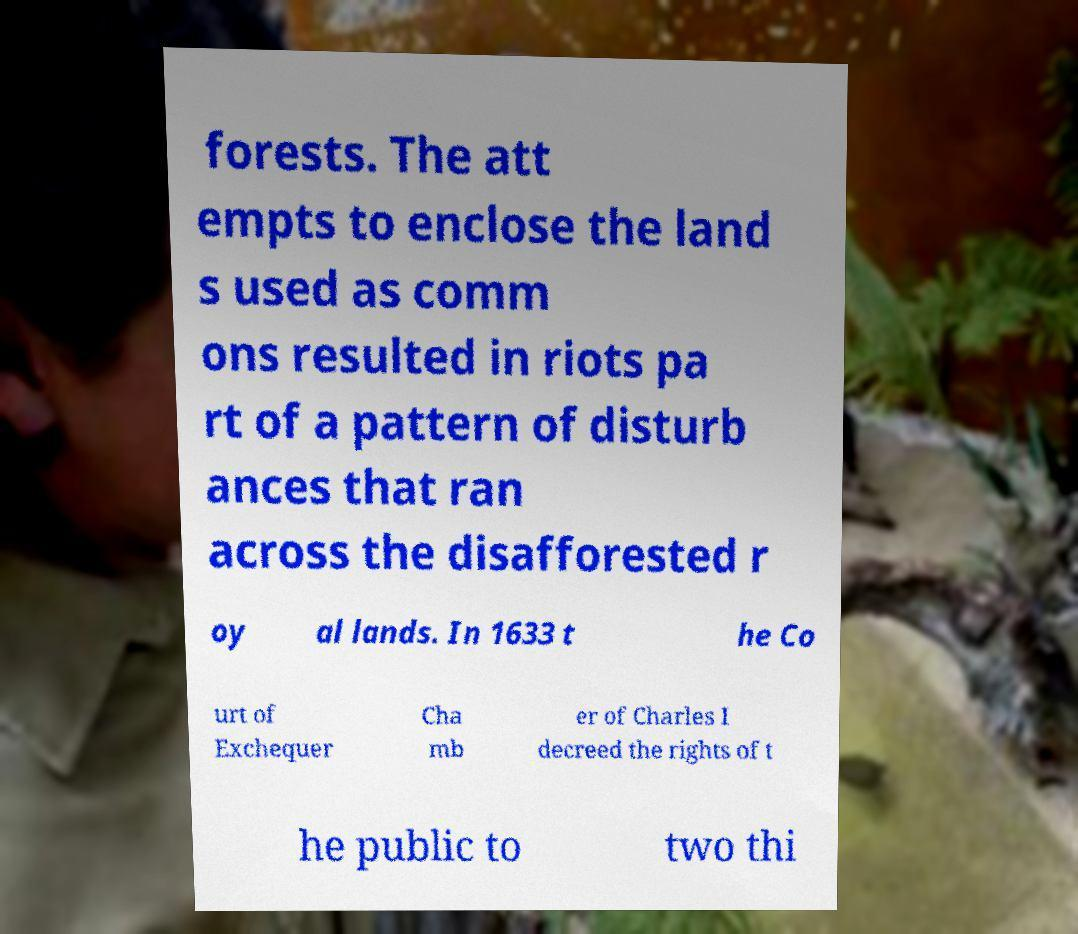Could you extract and type out the text from this image? forests. The att empts to enclose the land s used as comm ons resulted in riots pa rt of a pattern of disturb ances that ran across the disafforested r oy al lands. In 1633 t he Co urt of Exchequer Cha mb er of Charles I decreed the rights of t he public to two thi 